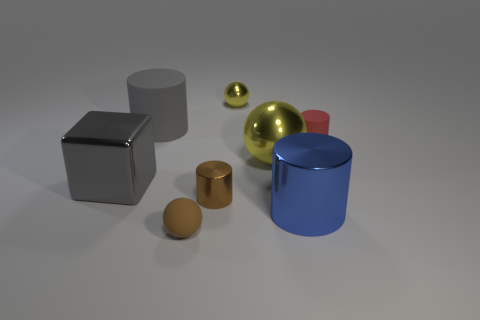Do these objects remind you of any particular setting or usage? These objects could remind someone of a minimalist art installation or an educational tool used for teaching geometry, physics, or art principles such as form, texture, and light interaction with different surfaces. 